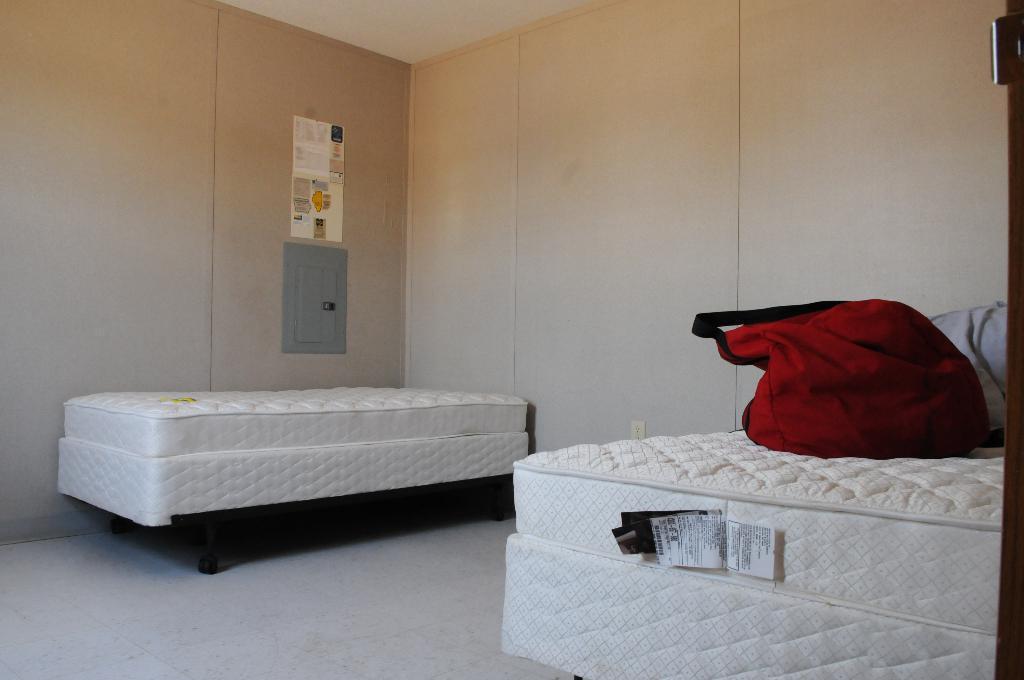Could you give a brief overview of what you see in this image? In this image there is one bed at left side of this image and one more at right side of this image. There is one bag kept on right side bed and there is a wall in the background. 